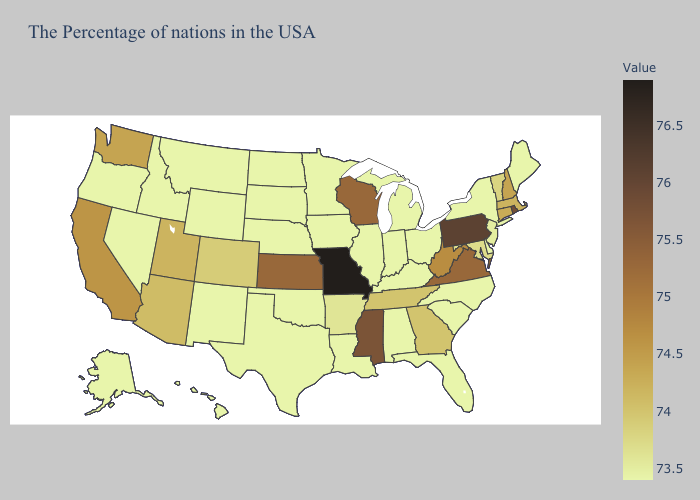Does Vermont have the highest value in the Northeast?
Keep it brief. No. Among the states that border Connecticut , which have the lowest value?
Quick response, please. New York. Is the legend a continuous bar?
Quick response, please. Yes. Does Louisiana have the lowest value in the South?
Concise answer only. Yes. Which states hav the highest value in the West?
Give a very brief answer. California. Does Connecticut have the lowest value in the USA?
Short answer required. No. Which states hav the highest value in the West?
Concise answer only. California. Which states have the lowest value in the West?
Short answer required. Wyoming, New Mexico, Montana, Idaho, Nevada, Oregon, Alaska, Hawaii. 